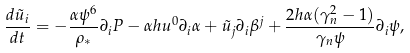Convert formula to latex. <formula><loc_0><loc_0><loc_500><loc_500>\frac { d \tilde { u } _ { i } } { d t } = - \frac { \alpha \psi ^ { 6 } } { \rho _ { * } } \partial _ { i } P - \alpha h u ^ { 0 } \partial _ { i } \alpha + \tilde { u } _ { j } \partial _ { i } \beta ^ { j } + \frac { 2 h \alpha ( \gamma _ { n } ^ { 2 } - 1 ) } { \gamma _ { n } \psi } \partial _ { i } \psi ,</formula> 